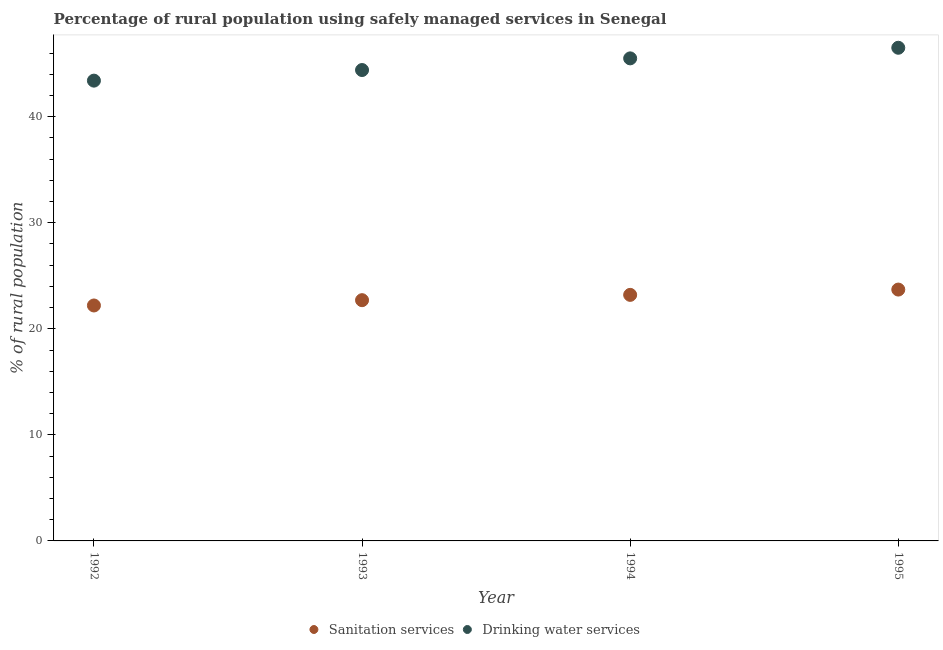Is the number of dotlines equal to the number of legend labels?
Provide a short and direct response. Yes. What is the percentage of rural population who used drinking water services in 1995?
Offer a terse response. 46.5. Across all years, what is the maximum percentage of rural population who used sanitation services?
Ensure brevity in your answer.  23.7. Across all years, what is the minimum percentage of rural population who used sanitation services?
Ensure brevity in your answer.  22.2. In which year was the percentage of rural population who used drinking water services maximum?
Your answer should be compact. 1995. What is the total percentage of rural population who used drinking water services in the graph?
Offer a terse response. 179.8. What is the difference between the percentage of rural population who used drinking water services in 1992 and that in 1993?
Your response must be concise. -1. What is the difference between the percentage of rural population who used drinking water services in 1995 and the percentage of rural population who used sanitation services in 1992?
Ensure brevity in your answer.  24.3. What is the average percentage of rural population who used drinking water services per year?
Offer a very short reply. 44.95. In the year 1992, what is the difference between the percentage of rural population who used sanitation services and percentage of rural population who used drinking water services?
Give a very brief answer. -21.2. In how many years, is the percentage of rural population who used sanitation services greater than 22 %?
Your answer should be compact. 4. What is the ratio of the percentage of rural population who used sanitation services in 1992 to that in 1995?
Offer a terse response. 0.94. Is the percentage of rural population who used sanitation services in 1992 less than that in 1995?
Offer a terse response. Yes. What is the difference between the highest and the lowest percentage of rural population who used sanitation services?
Provide a short and direct response. 1.5. How many dotlines are there?
Give a very brief answer. 2. How many years are there in the graph?
Offer a terse response. 4. What is the difference between two consecutive major ticks on the Y-axis?
Offer a very short reply. 10. Are the values on the major ticks of Y-axis written in scientific E-notation?
Your answer should be compact. No. Does the graph contain any zero values?
Provide a succinct answer. No. How many legend labels are there?
Provide a short and direct response. 2. How are the legend labels stacked?
Provide a short and direct response. Horizontal. What is the title of the graph?
Your answer should be compact. Percentage of rural population using safely managed services in Senegal. Does "Canada" appear as one of the legend labels in the graph?
Offer a very short reply. No. What is the label or title of the Y-axis?
Your response must be concise. % of rural population. What is the % of rural population in Sanitation services in 1992?
Offer a terse response. 22.2. What is the % of rural population of Drinking water services in 1992?
Your answer should be very brief. 43.4. What is the % of rural population of Sanitation services in 1993?
Keep it short and to the point. 22.7. What is the % of rural population of Drinking water services in 1993?
Provide a succinct answer. 44.4. What is the % of rural population in Sanitation services in 1994?
Provide a short and direct response. 23.2. What is the % of rural population in Drinking water services in 1994?
Keep it short and to the point. 45.5. What is the % of rural population of Sanitation services in 1995?
Offer a terse response. 23.7. What is the % of rural population in Drinking water services in 1995?
Ensure brevity in your answer.  46.5. Across all years, what is the maximum % of rural population in Sanitation services?
Your response must be concise. 23.7. Across all years, what is the maximum % of rural population of Drinking water services?
Offer a very short reply. 46.5. Across all years, what is the minimum % of rural population in Sanitation services?
Keep it short and to the point. 22.2. Across all years, what is the minimum % of rural population in Drinking water services?
Your answer should be very brief. 43.4. What is the total % of rural population in Sanitation services in the graph?
Your answer should be very brief. 91.8. What is the total % of rural population in Drinking water services in the graph?
Your answer should be compact. 179.8. What is the difference between the % of rural population of Sanitation services in 1992 and that in 1993?
Your response must be concise. -0.5. What is the difference between the % of rural population in Sanitation services in 1992 and that in 1995?
Your answer should be very brief. -1.5. What is the difference between the % of rural population of Sanitation services in 1993 and that in 1994?
Make the answer very short. -0.5. What is the difference between the % of rural population in Drinking water services in 1993 and that in 1994?
Offer a very short reply. -1.1. What is the difference between the % of rural population in Sanitation services in 1993 and that in 1995?
Provide a succinct answer. -1. What is the difference between the % of rural population of Drinking water services in 1993 and that in 1995?
Give a very brief answer. -2.1. What is the difference between the % of rural population of Sanitation services in 1994 and that in 1995?
Ensure brevity in your answer.  -0.5. What is the difference between the % of rural population in Sanitation services in 1992 and the % of rural population in Drinking water services in 1993?
Give a very brief answer. -22.2. What is the difference between the % of rural population of Sanitation services in 1992 and the % of rural population of Drinking water services in 1994?
Your response must be concise. -23.3. What is the difference between the % of rural population of Sanitation services in 1992 and the % of rural population of Drinking water services in 1995?
Give a very brief answer. -24.3. What is the difference between the % of rural population in Sanitation services in 1993 and the % of rural population in Drinking water services in 1994?
Your answer should be very brief. -22.8. What is the difference between the % of rural population of Sanitation services in 1993 and the % of rural population of Drinking water services in 1995?
Make the answer very short. -23.8. What is the difference between the % of rural population in Sanitation services in 1994 and the % of rural population in Drinking water services in 1995?
Your response must be concise. -23.3. What is the average % of rural population of Sanitation services per year?
Make the answer very short. 22.95. What is the average % of rural population in Drinking water services per year?
Provide a succinct answer. 44.95. In the year 1992, what is the difference between the % of rural population in Sanitation services and % of rural population in Drinking water services?
Make the answer very short. -21.2. In the year 1993, what is the difference between the % of rural population in Sanitation services and % of rural population in Drinking water services?
Provide a short and direct response. -21.7. In the year 1994, what is the difference between the % of rural population in Sanitation services and % of rural population in Drinking water services?
Your answer should be very brief. -22.3. In the year 1995, what is the difference between the % of rural population in Sanitation services and % of rural population in Drinking water services?
Ensure brevity in your answer.  -22.8. What is the ratio of the % of rural population of Drinking water services in 1992 to that in 1993?
Provide a short and direct response. 0.98. What is the ratio of the % of rural population in Sanitation services in 1992 to that in 1994?
Give a very brief answer. 0.96. What is the ratio of the % of rural population of Drinking water services in 1992 to that in 1994?
Keep it short and to the point. 0.95. What is the ratio of the % of rural population in Sanitation services in 1992 to that in 1995?
Provide a succinct answer. 0.94. What is the ratio of the % of rural population of Sanitation services in 1993 to that in 1994?
Give a very brief answer. 0.98. What is the ratio of the % of rural population of Drinking water services in 1993 to that in 1994?
Provide a succinct answer. 0.98. What is the ratio of the % of rural population in Sanitation services in 1993 to that in 1995?
Your answer should be very brief. 0.96. What is the ratio of the % of rural population in Drinking water services in 1993 to that in 1995?
Give a very brief answer. 0.95. What is the ratio of the % of rural population of Sanitation services in 1994 to that in 1995?
Your answer should be compact. 0.98. What is the ratio of the % of rural population of Drinking water services in 1994 to that in 1995?
Keep it short and to the point. 0.98. What is the difference between the highest and the second highest % of rural population in Drinking water services?
Offer a terse response. 1. 